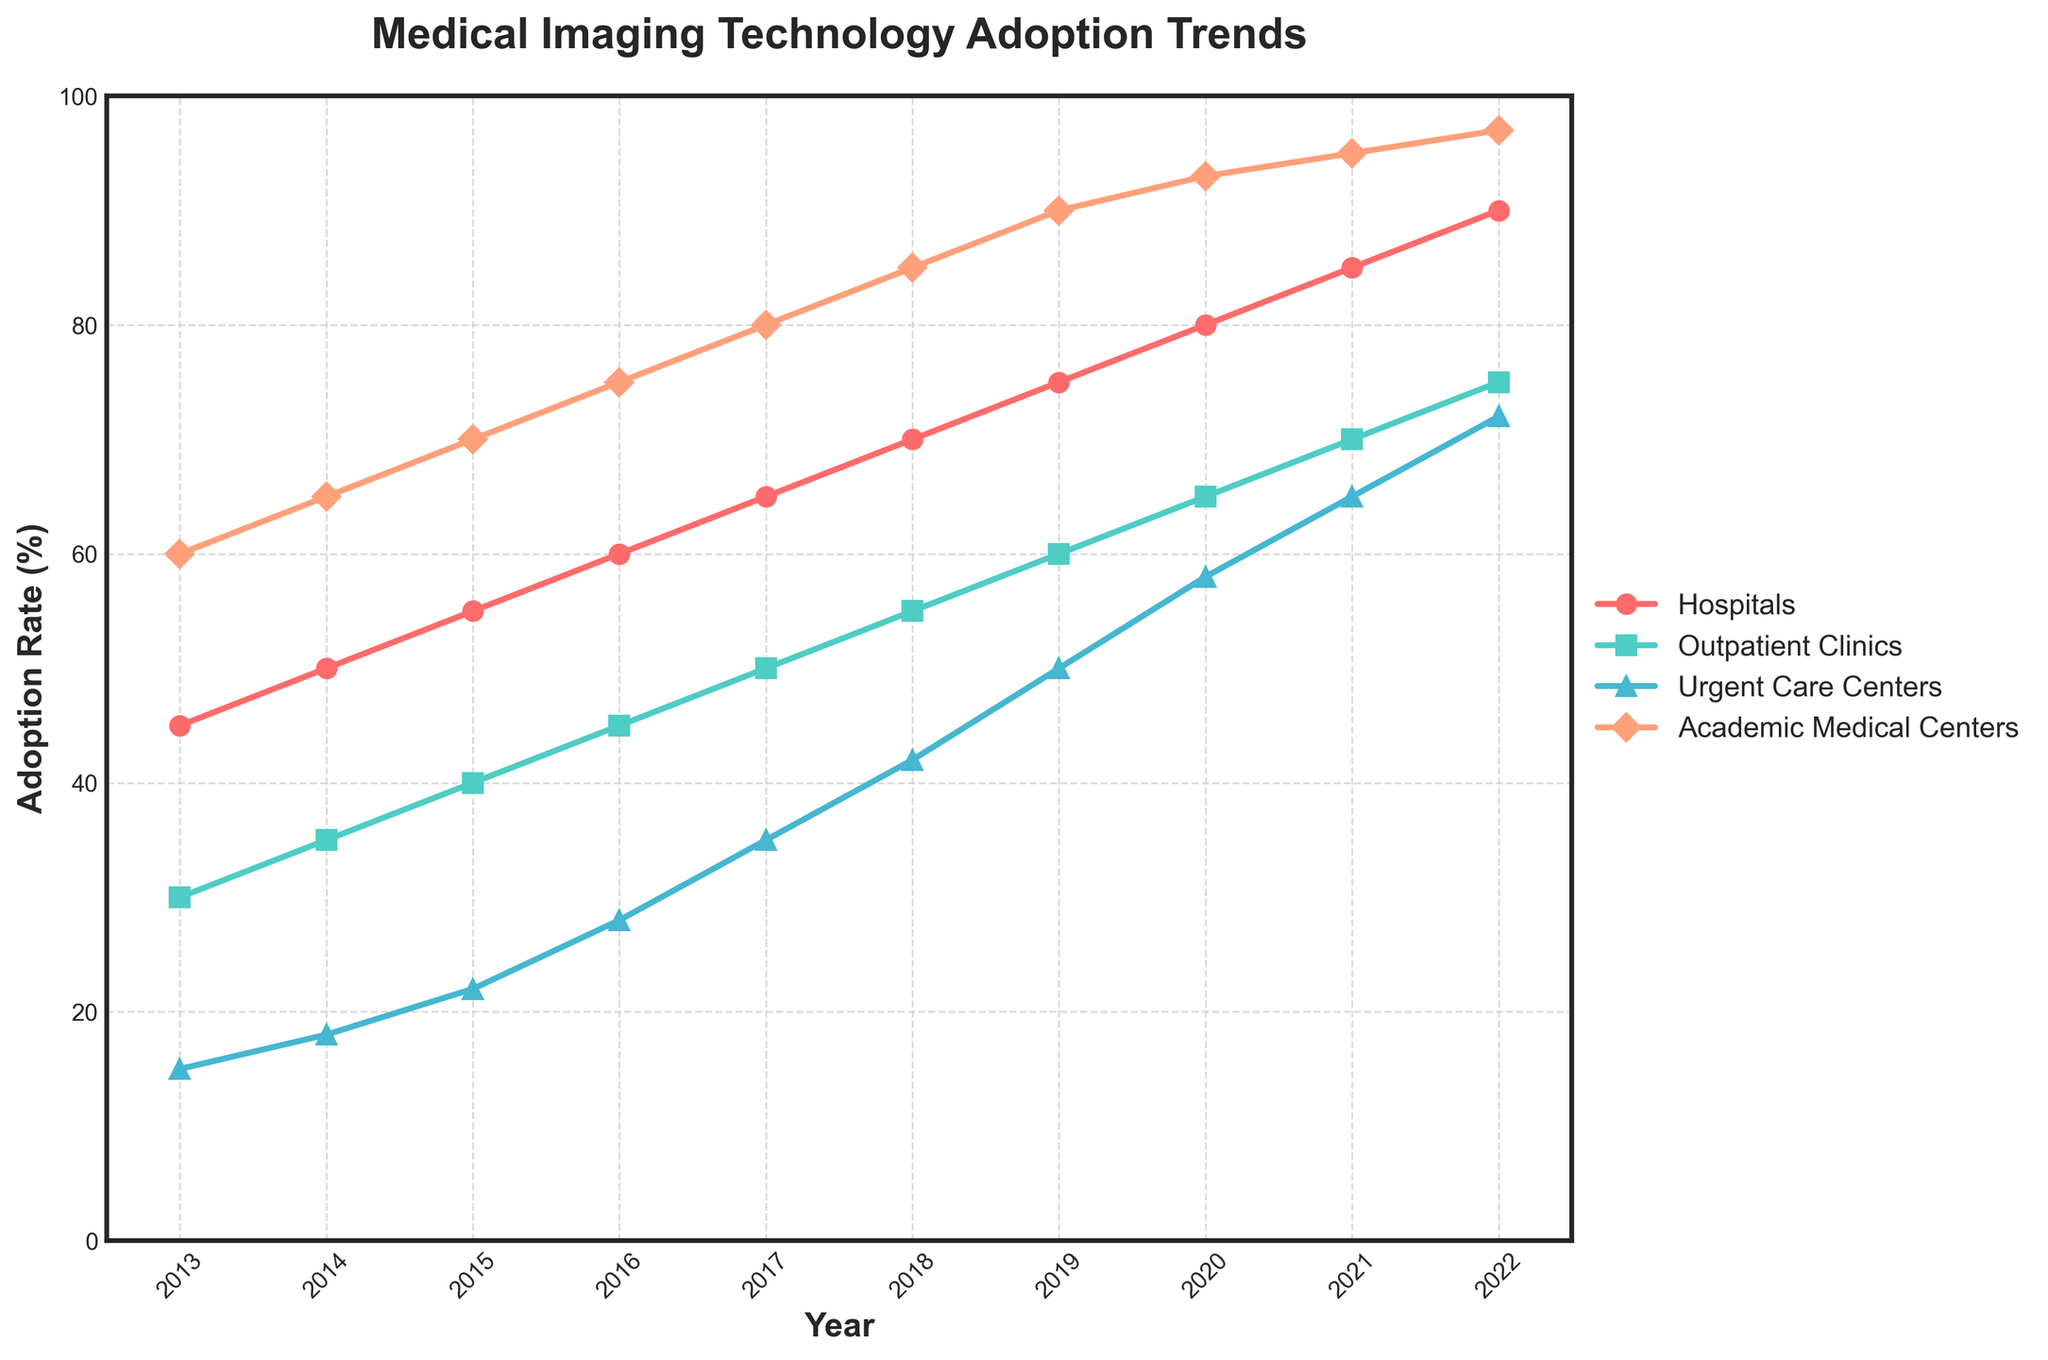Which healthcare facility shows the highest adoption rate of medical imaging technology in 2022? The chart shows the adoption rates for various healthcare facilities in 2022. By observing the endpoints of the lines in 2022, Academic Medical Centers have the highest value of 97%
Answer: Academic Medical Centers How did the adoption rate change for Urgent Care Centers between 2013 and 2022? To find the change in adoption rate, subtract the 2013 value (15%) from the 2022 value (72%) for Urgent Care Centers: 72% - 15%
Answer: 57% Which facility had the smallest increase in adoption rates from 2019 to 2020? Compare the differences for each facility between 2019 and 2020: Hospitals (80-75 = 5%), Outpatient Clinics (65-60 = 5%), Urgent Care Centers (58-50 = 8%), Academic Medical Centers (93-90 = 3%). The smallest increase is for Academic Medical Centers
Answer: Academic Medical Centers Which two facilities had equal adoption rates in any year? Checking the lines, we see that in 2018 Hospitals and Outpatient Clinics had the same adoption rate of 55%
Answer: Hospitals and Outpatient Clinics in 2018 What is the average adoption rate for Hospitals from 2013 to 2022? Sum up the adoption rates from 2013 to 2022 and divide by 10. (45+50+55+60+65+70+75+80+85+90)/10 = 67
Answer: 67% By how much did the adoption rate for Outpatient Clinics differ from Hospitals in 2017? Subtract Outpatient Clinics' adoption rate from Hospitals' adoption rate in 2017: 65% - 50%
Answer: 15% In which year did Urgent Care Centers first exceed a 50% adoption rate? Look at the data for Urgent Care Centers and the line's progression. It first exceeds 50% in 2019
Answer: 2019 If you total the adoption rates for all facility types in 2020, what value do you get? Add the values for all facility types in 2020: Hospitals (80) + Outpatient Clinics (65) + Urgent Care Centers (58) + Academic Medical Centers (93). 80 + 65 + 58 + 93 = 296
Answer: 296 What visual feature distinguishes the Academic Medical Centers' trend compared to the other facilities? The trend line for Academic Medical Centers is consistently the highest and is depicted with diamond markers
Answer: Diamond markers Which year saw the biggest increase in adoption rates for Hospitals? By comparing the year-to-year increases of Hospitals, the biggest increase was from 2013 to 2014 (50-45 = 5%), but from 2017 to 2018, it's also (70-65=5%). So there is a tie.
Answer: 2013-2014 and 2017-2018 (tie) 